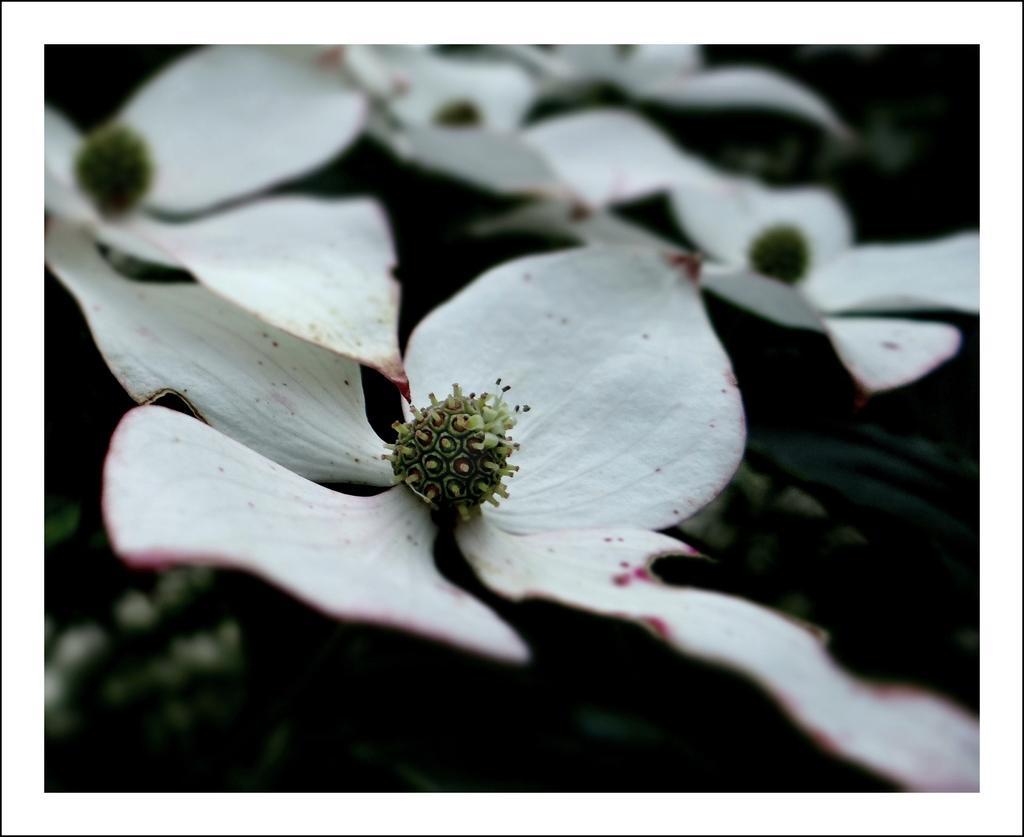In one or two sentences, can you explain what this image depicts? In this picture I can see white color flowers. 